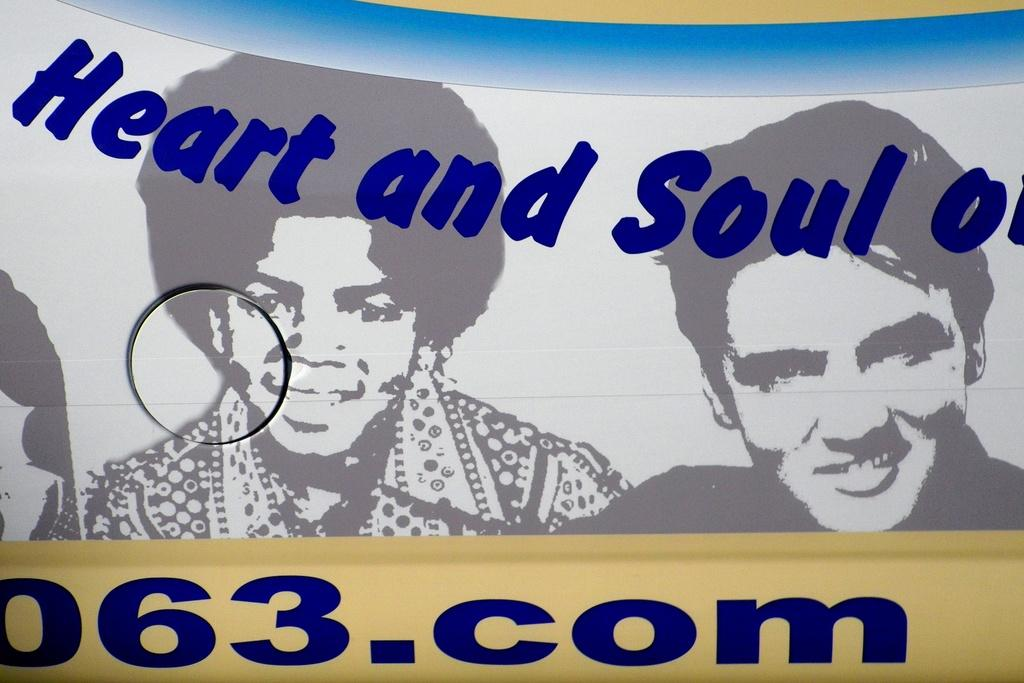What is present on the poster in the image? There is a poster in the image. What can be seen on the poster? The poster has images of two persons. What are the expressions of the persons on the poster? The persons on the poster are smiling. What color is the text on the poster? There are violet color texts on the poster. How many cows are present on the poster? There are no cows present on the poster; it features images of two persons. What rule is being enforced by the team in the image? There is no team or rule enforcement depicted in the image; it only shows a poster with images of two persons. 